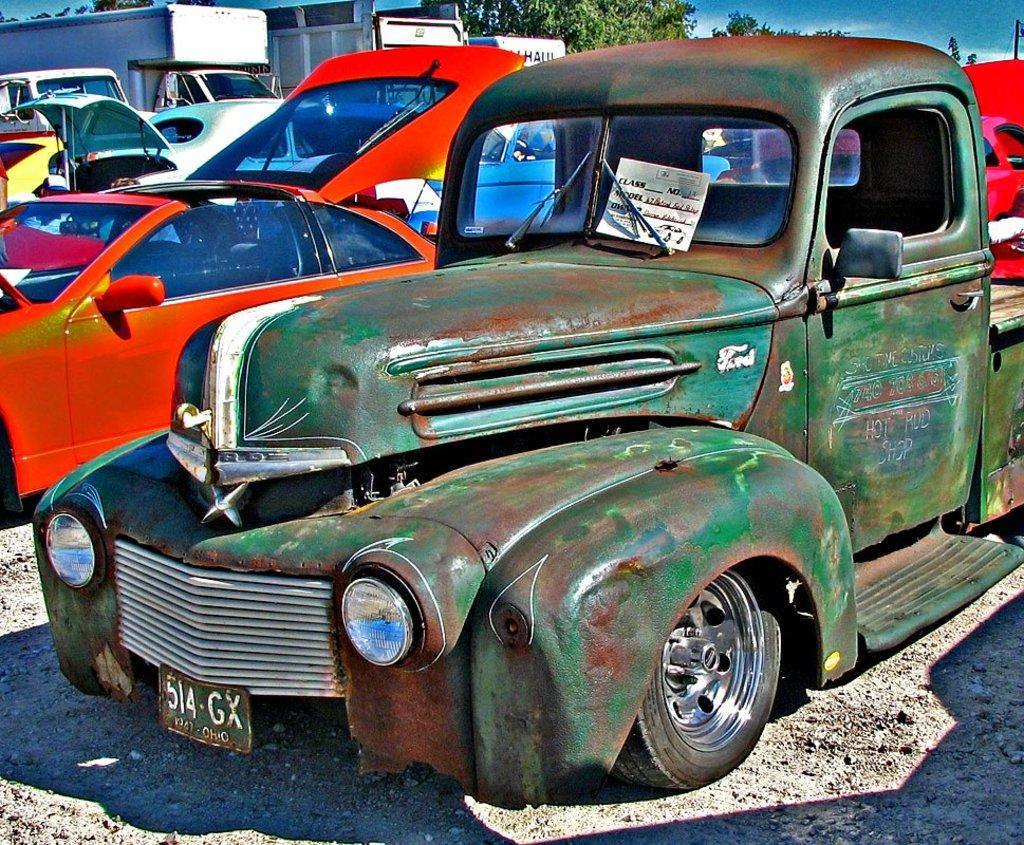What type of car is the main subject of the image? There is a green classic car in the image. Where is the classic car located in the image? The classic car is in the front of the image. Are there any other cars in the image? Yes, other cars are parked beside the classic car. What can be seen in the background of the image? There are trees visible in the background of the image. What type of company is the classic car associated with in the image? There is no indication of any company association with the classic car in the image. Can you tell me how many friends are sitting inside the classic car? There are no people visible inside the classic car in the image. 